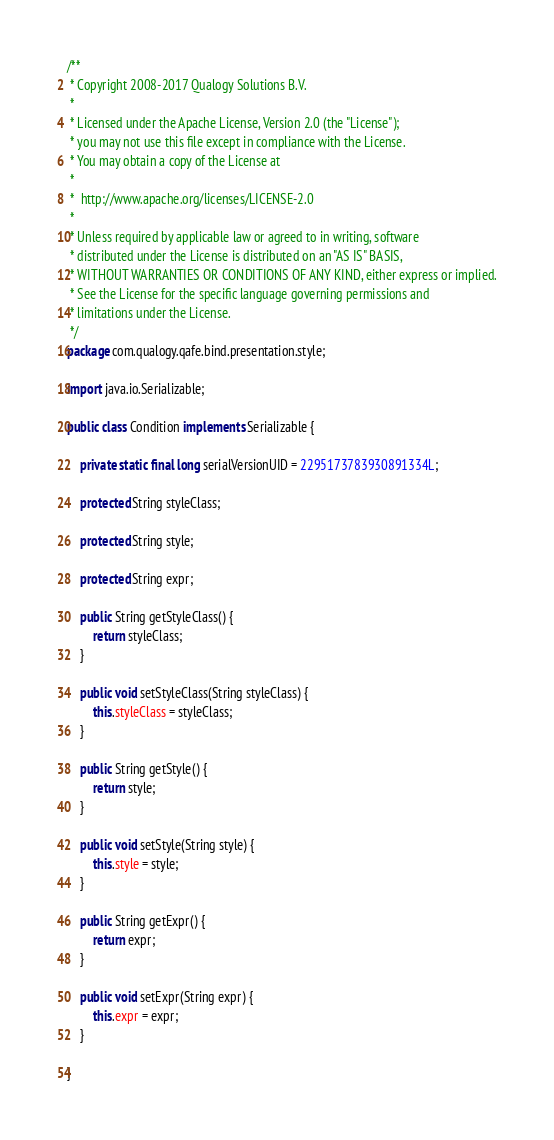<code> <loc_0><loc_0><loc_500><loc_500><_Java_>/**
 * Copyright 2008-2017 Qualogy Solutions B.V.
 *
 * Licensed under the Apache License, Version 2.0 (the "License");
 * you may not use this file except in compliance with the License.
 * You may obtain a copy of the License at
 *
 * 	http://www.apache.org/licenses/LICENSE-2.0
 *
 * Unless required by applicable law or agreed to in writing, software
 * distributed under the License is distributed on an "AS IS" BASIS,
 * WITHOUT WARRANTIES OR CONDITIONS OF ANY KIND, either express or implied.
 * See the License for the specific language governing permissions and
 * limitations under the License.
 */
package com.qualogy.qafe.bind.presentation.style;

import java.io.Serializable;

public class Condition implements Serializable {

	private static final long serialVersionUID = 2295173783930891334L;
	
	protected String styleClass;
	
	protected String style;
	
	protected String expr;

	public String getStyleClass() {
		return styleClass;
	}

	public void setStyleClass(String styleClass) {
		this.styleClass = styleClass;
	}

	public String getStyle() {
		return style;
	}

	public void setStyle(String style) {
		this.style = style;
	}

	public String getExpr() {
		return expr;
	}

	public void setExpr(String expr) {
		this.expr = expr;
	}

}
</code> 